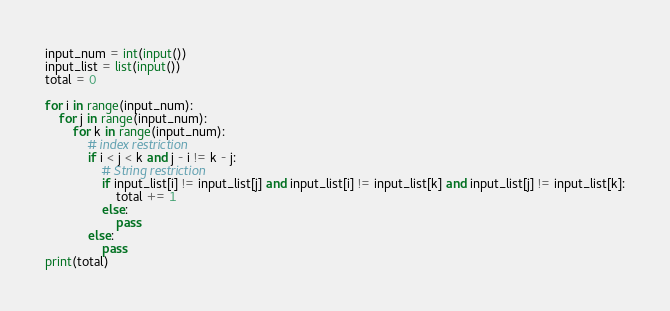<code> <loc_0><loc_0><loc_500><loc_500><_Python_>input_num = int(input())
input_list = list(input())
total = 0

for i in range(input_num):
    for j in range(input_num):
        for k in range(input_num):
            # index restriction
            if i < j < k and j - i != k - j:
                # String restriction
                if input_list[i] != input_list[j] and input_list[i] != input_list[k] and input_list[j] != input_list[k]:
                    total += 1
                else:
                    pass
            else:
                pass
print(total)
</code> 